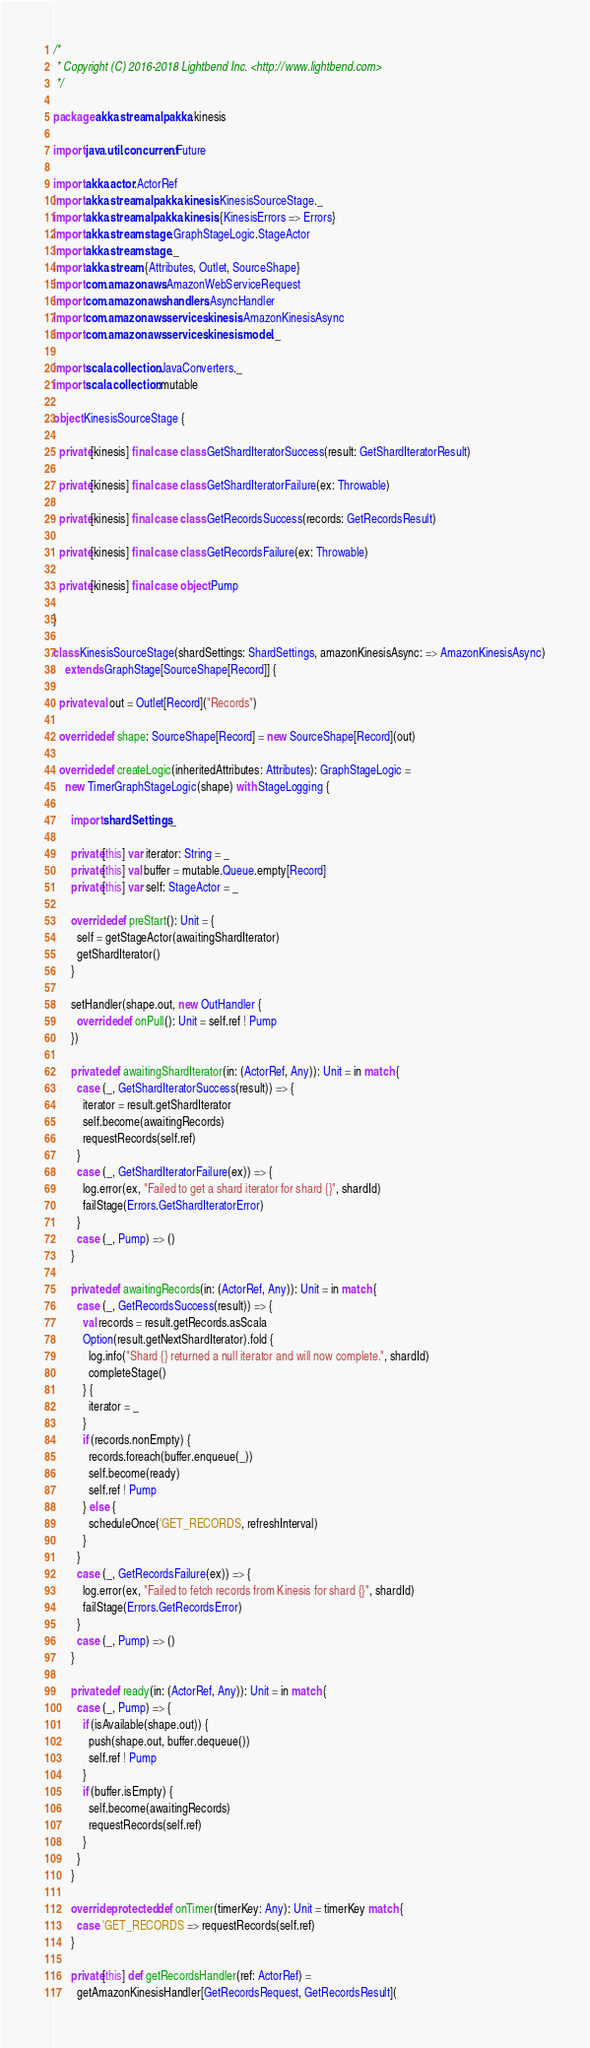<code> <loc_0><loc_0><loc_500><loc_500><_Scala_>/*
 * Copyright (C) 2016-2018 Lightbend Inc. <http://www.lightbend.com>
 */

package akka.stream.alpakka.kinesis

import java.util.concurrent.Future

import akka.actor.ActorRef
import akka.stream.alpakka.kinesis.KinesisSourceStage._
import akka.stream.alpakka.kinesis.{KinesisErrors => Errors}
import akka.stream.stage.GraphStageLogic.StageActor
import akka.stream.stage._
import akka.stream.{Attributes, Outlet, SourceShape}
import com.amazonaws.AmazonWebServiceRequest
import com.amazonaws.handlers.AsyncHandler
import com.amazonaws.services.kinesis.AmazonKinesisAsync
import com.amazonaws.services.kinesis.model._

import scala.collection.JavaConverters._
import scala.collection.mutable

object KinesisSourceStage {

  private[kinesis] final case class GetShardIteratorSuccess(result: GetShardIteratorResult)

  private[kinesis] final case class GetShardIteratorFailure(ex: Throwable)

  private[kinesis] final case class GetRecordsSuccess(records: GetRecordsResult)

  private[kinesis] final case class GetRecordsFailure(ex: Throwable)

  private[kinesis] final case object Pump

}

class KinesisSourceStage(shardSettings: ShardSettings, amazonKinesisAsync: => AmazonKinesisAsync)
    extends GraphStage[SourceShape[Record]] {

  private val out = Outlet[Record]("Records")

  override def shape: SourceShape[Record] = new SourceShape[Record](out)

  override def createLogic(inheritedAttributes: Attributes): GraphStageLogic =
    new TimerGraphStageLogic(shape) with StageLogging {

      import shardSettings._

      private[this] var iterator: String = _
      private[this] val buffer = mutable.Queue.empty[Record]
      private[this] var self: StageActor = _

      override def preStart(): Unit = {
        self = getStageActor(awaitingShardIterator)
        getShardIterator()
      }

      setHandler(shape.out, new OutHandler {
        override def onPull(): Unit = self.ref ! Pump
      })

      private def awaitingShardIterator(in: (ActorRef, Any)): Unit = in match {
        case (_, GetShardIteratorSuccess(result)) => {
          iterator = result.getShardIterator
          self.become(awaitingRecords)
          requestRecords(self.ref)
        }
        case (_, GetShardIteratorFailure(ex)) => {
          log.error(ex, "Failed to get a shard iterator for shard {}", shardId)
          failStage(Errors.GetShardIteratorError)
        }
        case (_, Pump) => ()
      }

      private def awaitingRecords(in: (ActorRef, Any)): Unit = in match {
        case (_, GetRecordsSuccess(result)) => {
          val records = result.getRecords.asScala
          Option(result.getNextShardIterator).fold {
            log.info("Shard {} returned a null iterator and will now complete.", shardId)
            completeStage()
          } {
            iterator = _
          }
          if (records.nonEmpty) {
            records.foreach(buffer.enqueue(_))
            self.become(ready)
            self.ref ! Pump
          } else {
            scheduleOnce('GET_RECORDS, refreshInterval)
          }
        }
        case (_, GetRecordsFailure(ex)) => {
          log.error(ex, "Failed to fetch records from Kinesis for shard {}", shardId)
          failStage(Errors.GetRecordsError)
        }
        case (_, Pump) => ()
      }

      private def ready(in: (ActorRef, Any)): Unit = in match {
        case (_, Pump) => {
          if (isAvailable(shape.out)) {
            push(shape.out, buffer.dequeue())
            self.ref ! Pump
          }
          if (buffer.isEmpty) {
            self.become(awaitingRecords)
            requestRecords(self.ref)
          }
        }
      }

      override protected def onTimer(timerKey: Any): Unit = timerKey match {
        case 'GET_RECORDS => requestRecords(self.ref)
      }

      private[this] def getRecordsHandler(ref: ActorRef) =
        getAmazonKinesisHandler[GetRecordsRequest, GetRecordsResult](</code> 